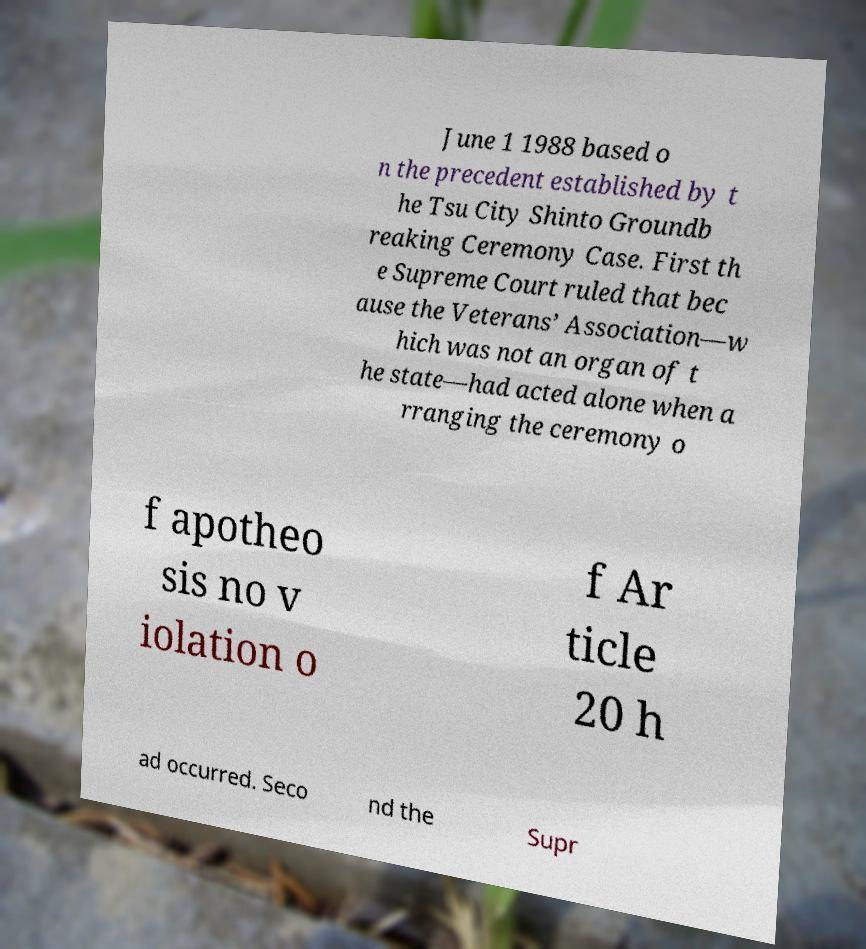Can you read and provide the text displayed in the image?This photo seems to have some interesting text. Can you extract and type it out for me? June 1 1988 based o n the precedent established by t he Tsu City Shinto Groundb reaking Ceremony Case. First th e Supreme Court ruled that bec ause the Veterans’ Association—w hich was not an organ of t he state—had acted alone when a rranging the ceremony o f apotheo sis no v iolation o f Ar ticle 20 h ad occurred. Seco nd the Supr 